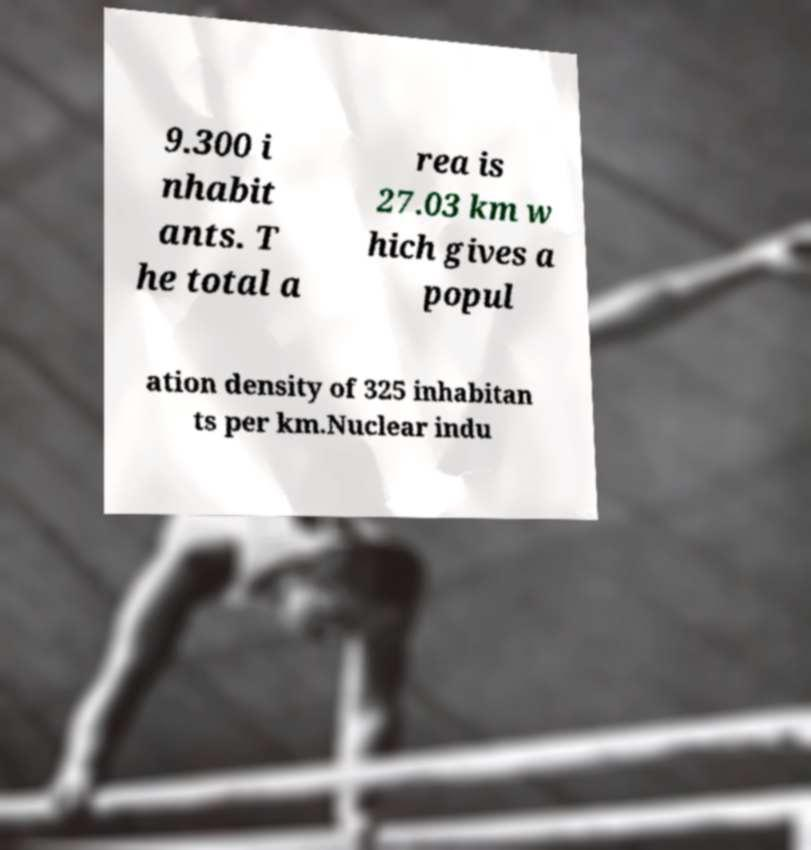Can you read and provide the text displayed in the image?This photo seems to have some interesting text. Can you extract and type it out for me? 9.300 i nhabit ants. T he total a rea is 27.03 km w hich gives a popul ation density of 325 inhabitan ts per km.Nuclear indu 